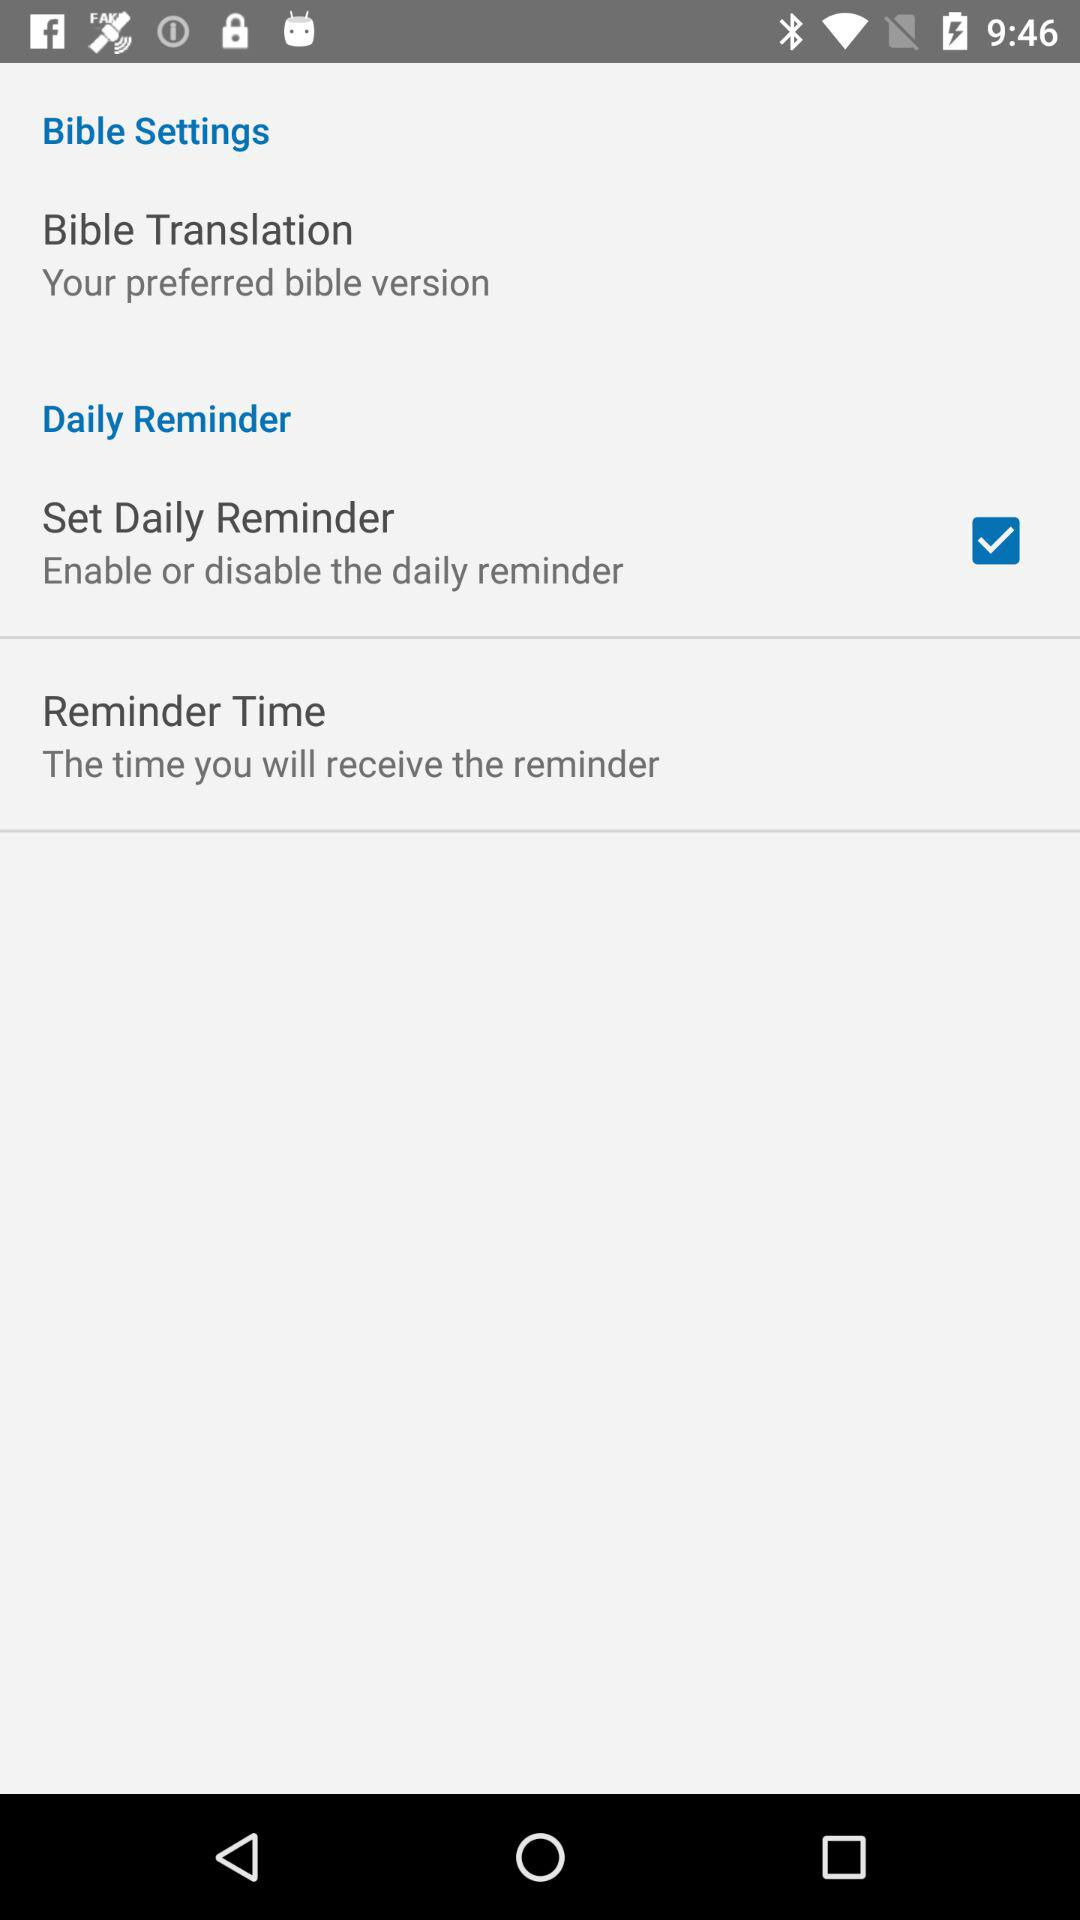What is the status of "Set Daily Reminder"? The status is "on". 